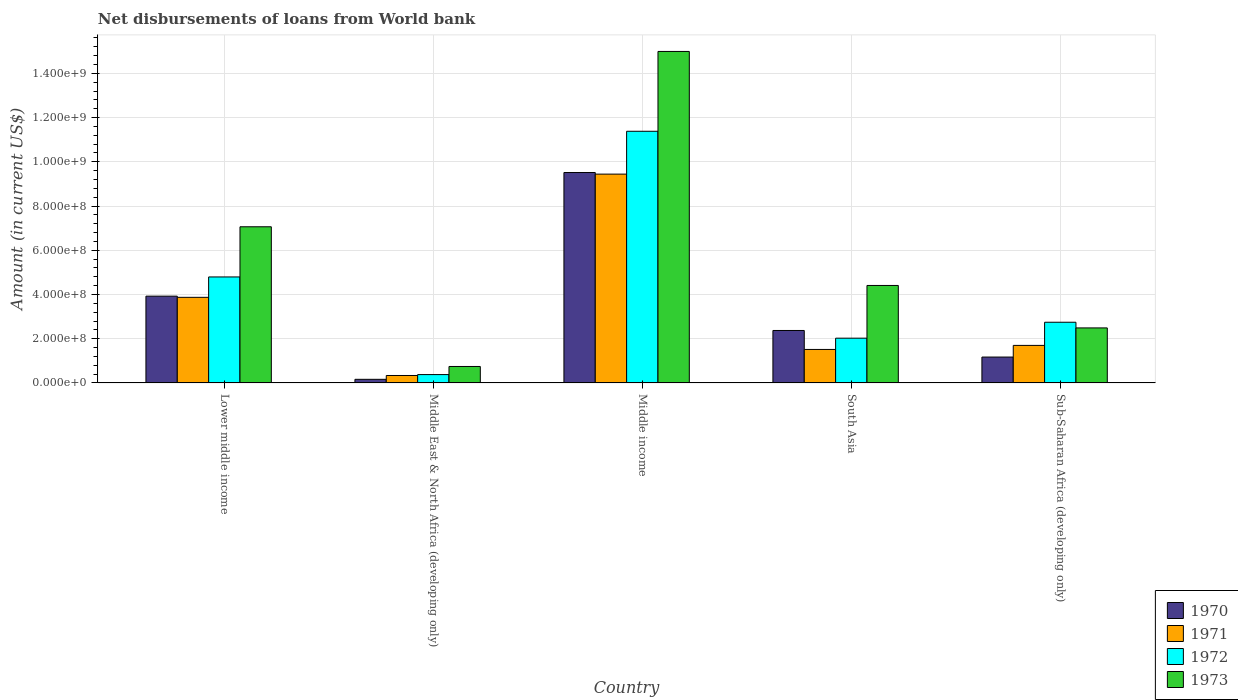Are the number of bars per tick equal to the number of legend labels?
Offer a very short reply. Yes. How many bars are there on the 5th tick from the right?
Make the answer very short. 4. What is the label of the 5th group of bars from the left?
Make the answer very short. Sub-Saharan Africa (developing only). In how many cases, is the number of bars for a given country not equal to the number of legend labels?
Provide a succinct answer. 0. What is the amount of loan disbursed from World Bank in 1973 in Lower middle income?
Give a very brief answer. 7.06e+08. Across all countries, what is the maximum amount of loan disbursed from World Bank in 1973?
Offer a terse response. 1.50e+09. Across all countries, what is the minimum amount of loan disbursed from World Bank in 1972?
Give a very brief answer. 3.77e+07. In which country was the amount of loan disbursed from World Bank in 1972 maximum?
Offer a very short reply. Middle income. In which country was the amount of loan disbursed from World Bank in 1973 minimum?
Keep it short and to the point. Middle East & North Africa (developing only). What is the total amount of loan disbursed from World Bank in 1970 in the graph?
Ensure brevity in your answer.  1.71e+09. What is the difference between the amount of loan disbursed from World Bank in 1971 in Middle income and that in South Asia?
Make the answer very short. 7.93e+08. What is the difference between the amount of loan disbursed from World Bank in 1971 in Middle income and the amount of loan disbursed from World Bank in 1972 in South Asia?
Provide a succinct answer. 7.42e+08. What is the average amount of loan disbursed from World Bank in 1973 per country?
Your answer should be very brief. 5.94e+08. What is the difference between the amount of loan disbursed from World Bank of/in 1970 and amount of loan disbursed from World Bank of/in 1971 in Lower middle income?
Offer a very short reply. 5.37e+06. In how many countries, is the amount of loan disbursed from World Bank in 1973 greater than 1320000000 US$?
Provide a succinct answer. 1. What is the ratio of the amount of loan disbursed from World Bank in 1971 in Middle income to that in Sub-Saharan Africa (developing only)?
Provide a succinct answer. 5.56. Is the amount of loan disbursed from World Bank in 1971 in Middle income less than that in Sub-Saharan Africa (developing only)?
Give a very brief answer. No. What is the difference between the highest and the second highest amount of loan disbursed from World Bank in 1972?
Your answer should be very brief. 8.63e+08. What is the difference between the highest and the lowest amount of loan disbursed from World Bank in 1970?
Offer a terse response. 9.35e+08. Is it the case that in every country, the sum of the amount of loan disbursed from World Bank in 1972 and amount of loan disbursed from World Bank in 1971 is greater than the sum of amount of loan disbursed from World Bank in 1970 and amount of loan disbursed from World Bank in 1973?
Keep it short and to the point. No. What does the 1st bar from the left in Middle East & North Africa (developing only) represents?
Keep it short and to the point. 1970. What does the 4th bar from the right in Middle East & North Africa (developing only) represents?
Keep it short and to the point. 1970. Is it the case that in every country, the sum of the amount of loan disbursed from World Bank in 1971 and amount of loan disbursed from World Bank in 1970 is greater than the amount of loan disbursed from World Bank in 1972?
Provide a short and direct response. Yes. How many bars are there?
Offer a terse response. 20. Does the graph contain any zero values?
Ensure brevity in your answer.  No. Does the graph contain grids?
Ensure brevity in your answer.  Yes. Where does the legend appear in the graph?
Give a very brief answer. Bottom right. What is the title of the graph?
Your response must be concise. Net disbursements of loans from World bank. Does "2011" appear as one of the legend labels in the graph?
Provide a short and direct response. No. What is the label or title of the Y-axis?
Provide a succinct answer. Amount (in current US$). What is the Amount (in current US$) of 1970 in Lower middle income?
Keep it short and to the point. 3.92e+08. What is the Amount (in current US$) of 1971 in Lower middle income?
Your answer should be very brief. 3.87e+08. What is the Amount (in current US$) in 1972 in Lower middle income?
Provide a succinct answer. 4.79e+08. What is the Amount (in current US$) of 1973 in Lower middle income?
Provide a succinct answer. 7.06e+08. What is the Amount (in current US$) of 1970 in Middle East & North Africa (developing only)?
Give a very brief answer. 1.64e+07. What is the Amount (in current US$) of 1971 in Middle East & North Africa (developing only)?
Offer a terse response. 3.37e+07. What is the Amount (in current US$) of 1972 in Middle East & North Africa (developing only)?
Offer a terse response. 3.77e+07. What is the Amount (in current US$) of 1973 in Middle East & North Africa (developing only)?
Make the answer very short. 7.45e+07. What is the Amount (in current US$) of 1970 in Middle income?
Ensure brevity in your answer.  9.51e+08. What is the Amount (in current US$) in 1971 in Middle income?
Keep it short and to the point. 9.44e+08. What is the Amount (in current US$) in 1972 in Middle income?
Provide a short and direct response. 1.14e+09. What is the Amount (in current US$) of 1973 in Middle income?
Your answer should be compact. 1.50e+09. What is the Amount (in current US$) of 1970 in South Asia?
Your answer should be very brief. 2.37e+08. What is the Amount (in current US$) in 1971 in South Asia?
Your answer should be compact. 1.51e+08. What is the Amount (in current US$) of 1972 in South Asia?
Your answer should be very brief. 2.02e+08. What is the Amount (in current US$) of 1973 in South Asia?
Make the answer very short. 4.41e+08. What is the Amount (in current US$) of 1970 in Sub-Saharan Africa (developing only)?
Offer a very short reply. 1.17e+08. What is the Amount (in current US$) in 1971 in Sub-Saharan Africa (developing only)?
Provide a short and direct response. 1.70e+08. What is the Amount (in current US$) of 1972 in Sub-Saharan Africa (developing only)?
Offer a terse response. 2.74e+08. What is the Amount (in current US$) in 1973 in Sub-Saharan Africa (developing only)?
Offer a very short reply. 2.49e+08. Across all countries, what is the maximum Amount (in current US$) of 1970?
Offer a very short reply. 9.51e+08. Across all countries, what is the maximum Amount (in current US$) in 1971?
Provide a short and direct response. 9.44e+08. Across all countries, what is the maximum Amount (in current US$) of 1972?
Offer a very short reply. 1.14e+09. Across all countries, what is the maximum Amount (in current US$) of 1973?
Provide a short and direct response. 1.50e+09. Across all countries, what is the minimum Amount (in current US$) in 1970?
Provide a succinct answer. 1.64e+07. Across all countries, what is the minimum Amount (in current US$) of 1971?
Your answer should be very brief. 3.37e+07. Across all countries, what is the minimum Amount (in current US$) of 1972?
Offer a terse response. 3.77e+07. Across all countries, what is the minimum Amount (in current US$) in 1973?
Your answer should be very brief. 7.45e+07. What is the total Amount (in current US$) of 1970 in the graph?
Provide a short and direct response. 1.71e+09. What is the total Amount (in current US$) in 1971 in the graph?
Your answer should be compact. 1.69e+09. What is the total Amount (in current US$) in 1972 in the graph?
Provide a short and direct response. 2.13e+09. What is the total Amount (in current US$) in 1973 in the graph?
Your answer should be very brief. 2.97e+09. What is the difference between the Amount (in current US$) of 1970 in Lower middle income and that in Middle East & North Africa (developing only)?
Ensure brevity in your answer.  3.76e+08. What is the difference between the Amount (in current US$) in 1971 in Lower middle income and that in Middle East & North Africa (developing only)?
Make the answer very short. 3.53e+08. What is the difference between the Amount (in current US$) in 1972 in Lower middle income and that in Middle East & North Africa (developing only)?
Make the answer very short. 4.41e+08. What is the difference between the Amount (in current US$) of 1973 in Lower middle income and that in Middle East & North Africa (developing only)?
Offer a terse response. 6.32e+08. What is the difference between the Amount (in current US$) of 1970 in Lower middle income and that in Middle income?
Give a very brief answer. -5.59e+08. What is the difference between the Amount (in current US$) in 1971 in Lower middle income and that in Middle income?
Your answer should be very brief. -5.57e+08. What is the difference between the Amount (in current US$) in 1972 in Lower middle income and that in Middle income?
Ensure brevity in your answer.  -6.59e+08. What is the difference between the Amount (in current US$) in 1973 in Lower middle income and that in Middle income?
Provide a succinct answer. -7.93e+08. What is the difference between the Amount (in current US$) of 1970 in Lower middle income and that in South Asia?
Make the answer very short. 1.55e+08. What is the difference between the Amount (in current US$) of 1971 in Lower middle income and that in South Asia?
Provide a succinct answer. 2.36e+08. What is the difference between the Amount (in current US$) of 1972 in Lower middle income and that in South Asia?
Your answer should be compact. 2.77e+08. What is the difference between the Amount (in current US$) in 1973 in Lower middle income and that in South Asia?
Your answer should be very brief. 2.65e+08. What is the difference between the Amount (in current US$) in 1970 in Lower middle income and that in Sub-Saharan Africa (developing only)?
Give a very brief answer. 2.75e+08. What is the difference between the Amount (in current US$) in 1971 in Lower middle income and that in Sub-Saharan Africa (developing only)?
Offer a terse response. 2.17e+08. What is the difference between the Amount (in current US$) in 1972 in Lower middle income and that in Sub-Saharan Africa (developing only)?
Ensure brevity in your answer.  2.05e+08. What is the difference between the Amount (in current US$) of 1973 in Lower middle income and that in Sub-Saharan Africa (developing only)?
Keep it short and to the point. 4.57e+08. What is the difference between the Amount (in current US$) in 1970 in Middle East & North Africa (developing only) and that in Middle income?
Make the answer very short. -9.35e+08. What is the difference between the Amount (in current US$) of 1971 in Middle East & North Africa (developing only) and that in Middle income?
Provide a succinct answer. -9.10e+08. What is the difference between the Amount (in current US$) in 1972 in Middle East & North Africa (developing only) and that in Middle income?
Your answer should be very brief. -1.10e+09. What is the difference between the Amount (in current US$) of 1973 in Middle East & North Africa (developing only) and that in Middle income?
Offer a terse response. -1.42e+09. What is the difference between the Amount (in current US$) of 1970 in Middle East & North Africa (developing only) and that in South Asia?
Make the answer very short. -2.21e+08. What is the difference between the Amount (in current US$) in 1971 in Middle East & North Africa (developing only) and that in South Asia?
Make the answer very short. -1.18e+08. What is the difference between the Amount (in current US$) of 1972 in Middle East & North Africa (developing only) and that in South Asia?
Ensure brevity in your answer.  -1.65e+08. What is the difference between the Amount (in current US$) in 1973 in Middle East & North Africa (developing only) and that in South Asia?
Make the answer very short. -3.66e+08. What is the difference between the Amount (in current US$) of 1970 in Middle East & North Africa (developing only) and that in Sub-Saharan Africa (developing only)?
Make the answer very short. -1.01e+08. What is the difference between the Amount (in current US$) of 1971 in Middle East & North Africa (developing only) and that in Sub-Saharan Africa (developing only)?
Your answer should be compact. -1.36e+08. What is the difference between the Amount (in current US$) in 1972 in Middle East & North Africa (developing only) and that in Sub-Saharan Africa (developing only)?
Keep it short and to the point. -2.37e+08. What is the difference between the Amount (in current US$) of 1973 in Middle East & North Africa (developing only) and that in Sub-Saharan Africa (developing only)?
Give a very brief answer. -1.74e+08. What is the difference between the Amount (in current US$) of 1970 in Middle income and that in South Asia?
Your answer should be very brief. 7.14e+08. What is the difference between the Amount (in current US$) of 1971 in Middle income and that in South Asia?
Your answer should be compact. 7.93e+08. What is the difference between the Amount (in current US$) in 1972 in Middle income and that in South Asia?
Your answer should be very brief. 9.36e+08. What is the difference between the Amount (in current US$) in 1973 in Middle income and that in South Asia?
Offer a very short reply. 1.06e+09. What is the difference between the Amount (in current US$) in 1970 in Middle income and that in Sub-Saharan Africa (developing only)?
Make the answer very short. 8.34e+08. What is the difference between the Amount (in current US$) in 1971 in Middle income and that in Sub-Saharan Africa (developing only)?
Give a very brief answer. 7.74e+08. What is the difference between the Amount (in current US$) of 1972 in Middle income and that in Sub-Saharan Africa (developing only)?
Offer a very short reply. 8.63e+08. What is the difference between the Amount (in current US$) in 1973 in Middle income and that in Sub-Saharan Africa (developing only)?
Ensure brevity in your answer.  1.25e+09. What is the difference between the Amount (in current US$) in 1970 in South Asia and that in Sub-Saharan Africa (developing only)?
Your answer should be compact. 1.20e+08. What is the difference between the Amount (in current US$) of 1971 in South Asia and that in Sub-Saharan Africa (developing only)?
Provide a succinct answer. -1.83e+07. What is the difference between the Amount (in current US$) of 1972 in South Asia and that in Sub-Saharan Africa (developing only)?
Your response must be concise. -7.21e+07. What is the difference between the Amount (in current US$) in 1973 in South Asia and that in Sub-Saharan Africa (developing only)?
Your answer should be very brief. 1.92e+08. What is the difference between the Amount (in current US$) of 1970 in Lower middle income and the Amount (in current US$) of 1971 in Middle East & North Africa (developing only)?
Your answer should be compact. 3.59e+08. What is the difference between the Amount (in current US$) of 1970 in Lower middle income and the Amount (in current US$) of 1972 in Middle East & North Africa (developing only)?
Your answer should be compact. 3.55e+08. What is the difference between the Amount (in current US$) in 1970 in Lower middle income and the Amount (in current US$) in 1973 in Middle East & North Africa (developing only)?
Offer a terse response. 3.18e+08. What is the difference between the Amount (in current US$) in 1971 in Lower middle income and the Amount (in current US$) in 1972 in Middle East & North Africa (developing only)?
Keep it short and to the point. 3.49e+08. What is the difference between the Amount (in current US$) of 1971 in Lower middle income and the Amount (in current US$) of 1973 in Middle East & North Africa (developing only)?
Provide a succinct answer. 3.13e+08. What is the difference between the Amount (in current US$) of 1972 in Lower middle income and the Amount (in current US$) of 1973 in Middle East & North Africa (developing only)?
Provide a short and direct response. 4.05e+08. What is the difference between the Amount (in current US$) of 1970 in Lower middle income and the Amount (in current US$) of 1971 in Middle income?
Keep it short and to the point. -5.52e+08. What is the difference between the Amount (in current US$) of 1970 in Lower middle income and the Amount (in current US$) of 1972 in Middle income?
Your answer should be very brief. -7.46e+08. What is the difference between the Amount (in current US$) in 1970 in Lower middle income and the Amount (in current US$) in 1973 in Middle income?
Your answer should be compact. -1.11e+09. What is the difference between the Amount (in current US$) in 1971 in Lower middle income and the Amount (in current US$) in 1972 in Middle income?
Ensure brevity in your answer.  -7.51e+08. What is the difference between the Amount (in current US$) in 1971 in Lower middle income and the Amount (in current US$) in 1973 in Middle income?
Offer a terse response. -1.11e+09. What is the difference between the Amount (in current US$) of 1972 in Lower middle income and the Amount (in current US$) of 1973 in Middle income?
Make the answer very short. -1.02e+09. What is the difference between the Amount (in current US$) of 1970 in Lower middle income and the Amount (in current US$) of 1971 in South Asia?
Keep it short and to the point. 2.41e+08. What is the difference between the Amount (in current US$) of 1970 in Lower middle income and the Amount (in current US$) of 1972 in South Asia?
Your response must be concise. 1.90e+08. What is the difference between the Amount (in current US$) in 1970 in Lower middle income and the Amount (in current US$) in 1973 in South Asia?
Ensure brevity in your answer.  -4.83e+07. What is the difference between the Amount (in current US$) of 1971 in Lower middle income and the Amount (in current US$) of 1972 in South Asia?
Ensure brevity in your answer.  1.85e+08. What is the difference between the Amount (in current US$) in 1971 in Lower middle income and the Amount (in current US$) in 1973 in South Asia?
Your answer should be compact. -5.37e+07. What is the difference between the Amount (in current US$) of 1972 in Lower middle income and the Amount (in current US$) of 1973 in South Asia?
Your answer should be compact. 3.85e+07. What is the difference between the Amount (in current US$) in 1970 in Lower middle income and the Amount (in current US$) in 1971 in Sub-Saharan Africa (developing only)?
Your response must be concise. 2.23e+08. What is the difference between the Amount (in current US$) of 1970 in Lower middle income and the Amount (in current US$) of 1972 in Sub-Saharan Africa (developing only)?
Provide a short and direct response. 1.18e+08. What is the difference between the Amount (in current US$) in 1970 in Lower middle income and the Amount (in current US$) in 1973 in Sub-Saharan Africa (developing only)?
Offer a terse response. 1.44e+08. What is the difference between the Amount (in current US$) in 1971 in Lower middle income and the Amount (in current US$) in 1972 in Sub-Saharan Africa (developing only)?
Give a very brief answer. 1.13e+08. What is the difference between the Amount (in current US$) of 1971 in Lower middle income and the Amount (in current US$) of 1973 in Sub-Saharan Africa (developing only)?
Give a very brief answer. 1.38e+08. What is the difference between the Amount (in current US$) in 1972 in Lower middle income and the Amount (in current US$) in 1973 in Sub-Saharan Africa (developing only)?
Ensure brevity in your answer.  2.30e+08. What is the difference between the Amount (in current US$) of 1970 in Middle East & North Africa (developing only) and the Amount (in current US$) of 1971 in Middle income?
Provide a short and direct response. -9.28e+08. What is the difference between the Amount (in current US$) in 1970 in Middle East & North Africa (developing only) and the Amount (in current US$) in 1972 in Middle income?
Your answer should be very brief. -1.12e+09. What is the difference between the Amount (in current US$) in 1970 in Middle East & North Africa (developing only) and the Amount (in current US$) in 1973 in Middle income?
Your response must be concise. -1.48e+09. What is the difference between the Amount (in current US$) in 1971 in Middle East & North Africa (developing only) and the Amount (in current US$) in 1972 in Middle income?
Keep it short and to the point. -1.10e+09. What is the difference between the Amount (in current US$) in 1971 in Middle East & North Africa (developing only) and the Amount (in current US$) in 1973 in Middle income?
Offer a very short reply. -1.47e+09. What is the difference between the Amount (in current US$) of 1972 in Middle East & North Africa (developing only) and the Amount (in current US$) of 1973 in Middle income?
Give a very brief answer. -1.46e+09. What is the difference between the Amount (in current US$) in 1970 in Middle East & North Africa (developing only) and the Amount (in current US$) in 1971 in South Asia?
Your answer should be very brief. -1.35e+08. What is the difference between the Amount (in current US$) of 1970 in Middle East & North Africa (developing only) and the Amount (in current US$) of 1972 in South Asia?
Your answer should be very brief. -1.86e+08. What is the difference between the Amount (in current US$) of 1970 in Middle East & North Africa (developing only) and the Amount (in current US$) of 1973 in South Asia?
Your response must be concise. -4.24e+08. What is the difference between the Amount (in current US$) of 1971 in Middle East & North Africa (developing only) and the Amount (in current US$) of 1972 in South Asia?
Give a very brief answer. -1.69e+08. What is the difference between the Amount (in current US$) of 1971 in Middle East & North Africa (developing only) and the Amount (in current US$) of 1973 in South Asia?
Keep it short and to the point. -4.07e+08. What is the difference between the Amount (in current US$) in 1972 in Middle East & North Africa (developing only) and the Amount (in current US$) in 1973 in South Asia?
Your response must be concise. -4.03e+08. What is the difference between the Amount (in current US$) of 1970 in Middle East & North Africa (developing only) and the Amount (in current US$) of 1971 in Sub-Saharan Africa (developing only)?
Your answer should be very brief. -1.53e+08. What is the difference between the Amount (in current US$) in 1970 in Middle East & North Africa (developing only) and the Amount (in current US$) in 1972 in Sub-Saharan Africa (developing only)?
Offer a very short reply. -2.58e+08. What is the difference between the Amount (in current US$) of 1970 in Middle East & North Africa (developing only) and the Amount (in current US$) of 1973 in Sub-Saharan Africa (developing only)?
Make the answer very short. -2.32e+08. What is the difference between the Amount (in current US$) of 1971 in Middle East & North Africa (developing only) and the Amount (in current US$) of 1972 in Sub-Saharan Africa (developing only)?
Keep it short and to the point. -2.41e+08. What is the difference between the Amount (in current US$) in 1971 in Middle East & North Africa (developing only) and the Amount (in current US$) in 1973 in Sub-Saharan Africa (developing only)?
Ensure brevity in your answer.  -2.15e+08. What is the difference between the Amount (in current US$) of 1972 in Middle East & North Africa (developing only) and the Amount (in current US$) of 1973 in Sub-Saharan Africa (developing only)?
Provide a succinct answer. -2.11e+08. What is the difference between the Amount (in current US$) in 1970 in Middle income and the Amount (in current US$) in 1971 in South Asia?
Provide a succinct answer. 8.00e+08. What is the difference between the Amount (in current US$) in 1970 in Middle income and the Amount (in current US$) in 1972 in South Asia?
Keep it short and to the point. 7.49e+08. What is the difference between the Amount (in current US$) in 1970 in Middle income and the Amount (in current US$) in 1973 in South Asia?
Ensure brevity in your answer.  5.11e+08. What is the difference between the Amount (in current US$) of 1971 in Middle income and the Amount (in current US$) of 1972 in South Asia?
Give a very brief answer. 7.42e+08. What is the difference between the Amount (in current US$) in 1971 in Middle income and the Amount (in current US$) in 1973 in South Asia?
Ensure brevity in your answer.  5.03e+08. What is the difference between the Amount (in current US$) of 1972 in Middle income and the Amount (in current US$) of 1973 in South Asia?
Ensure brevity in your answer.  6.97e+08. What is the difference between the Amount (in current US$) of 1970 in Middle income and the Amount (in current US$) of 1971 in Sub-Saharan Africa (developing only)?
Offer a very short reply. 7.82e+08. What is the difference between the Amount (in current US$) in 1970 in Middle income and the Amount (in current US$) in 1972 in Sub-Saharan Africa (developing only)?
Your answer should be compact. 6.77e+08. What is the difference between the Amount (in current US$) of 1970 in Middle income and the Amount (in current US$) of 1973 in Sub-Saharan Africa (developing only)?
Offer a terse response. 7.03e+08. What is the difference between the Amount (in current US$) in 1971 in Middle income and the Amount (in current US$) in 1972 in Sub-Saharan Africa (developing only)?
Provide a short and direct response. 6.70e+08. What is the difference between the Amount (in current US$) in 1971 in Middle income and the Amount (in current US$) in 1973 in Sub-Saharan Africa (developing only)?
Make the answer very short. 6.95e+08. What is the difference between the Amount (in current US$) of 1972 in Middle income and the Amount (in current US$) of 1973 in Sub-Saharan Africa (developing only)?
Ensure brevity in your answer.  8.89e+08. What is the difference between the Amount (in current US$) in 1970 in South Asia and the Amount (in current US$) in 1971 in Sub-Saharan Africa (developing only)?
Offer a terse response. 6.75e+07. What is the difference between the Amount (in current US$) of 1970 in South Asia and the Amount (in current US$) of 1972 in Sub-Saharan Africa (developing only)?
Provide a short and direct response. -3.73e+07. What is the difference between the Amount (in current US$) in 1970 in South Asia and the Amount (in current US$) in 1973 in Sub-Saharan Africa (developing only)?
Offer a terse response. -1.16e+07. What is the difference between the Amount (in current US$) in 1971 in South Asia and the Amount (in current US$) in 1972 in Sub-Saharan Africa (developing only)?
Provide a short and direct response. -1.23e+08. What is the difference between the Amount (in current US$) in 1971 in South Asia and the Amount (in current US$) in 1973 in Sub-Saharan Africa (developing only)?
Make the answer very short. -9.74e+07. What is the difference between the Amount (in current US$) in 1972 in South Asia and the Amount (in current US$) in 1973 in Sub-Saharan Africa (developing only)?
Offer a terse response. -4.65e+07. What is the average Amount (in current US$) of 1970 per country?
Your answer should be very brief. 3.43e+08. What is the average Amount (in current US$) in 1971 per country?
Provide a short and direct response. 3.37e+08. What is the average Amount (in current US$) in 1972 per country?
Give a very brief answer. 4.26e+08. What is the average Amount (in current US$) of 1973 per country?
Offer a terse response. 5.94e+08. What is the difference between the Amount (in current US$) in 1970 and Amount (in current US$) in 1971 in Lower middle income?
Your answer should be compact. 5.37e+06. What is the difference between the Amount (in current US$) of 1970 and Amount (in current US$) of 1972 in Lower middle income?
Your answer should be very brief. -8.68e+07. What is the difference between the Amount (in current US$) in 1970 and Amount (in current US$) in 1973 in Lower middle income?
Offer a very short reply. -3.14e+08. What is the difference between the Amount (in current US$) in 1971 and Amount (in current US$) in 1972 in Lower middle income?
Ensure brevity in your answer.  -9.22e+07. What is the difference between the Amount (in current US$) of 1971 and Amount (in current US$) of 1973 in Lower middle income?
Give a very brief answer. -3.19e+08. What is the difference between the Amount (in current US$) of 1972 and Amount (in current US$) of 1973 in Lower middle income?
Offer a very short reply. -2.27e+08. What is the difference between the Amount (in current US$) of 1970 and Amount (in current US$) of 1971 in Middle East & North Africa (developing only)?
Ensure brevity in your answer.  -1.73e+07. What is the difference between the Amount (in current US$) of 1970 and Amount (in current US$) of 1972 in Middle East & North Africa (developing only)?
Give a very brief answer. -2.14e+07. What is the difference between the Amount (in current US$) of 1970 and Amount (in current US$) of 1973 in Middle East & North Africa (developing only)?
Keep it short and to the point. -5.81e+07. What is the difference between the Amount (in current US$) of 1971 and Amount (in current US$) of 1972 in Middle East & North Africa (developing only)?
Provide a short and direct response. -4.06e+06. What is the difference between the Amount (in current US$) in 1971 and Amount (in current US$) in 1973 in Middle East & North Africa (developing only)?
Provide a short and direct response. -4.08e+07. What is the difference between the Amount (in current US$) of 1972 and Amount (in current US$) of 1973 in Middle East & North Africa (developing only)?
Your answer should be compact. -3.67e+07. What is the difference between the Amount (in current US$) in 1970 and Amount (in current US$) in 1971 in Middle income?
Provide a succinct answer. 7.21e+06. What is the difference between the Amount (in current US$) of 1970 and Amount (in current US$) of 1972 in Middle income?
Provide a short and direct response. -1.87e+08. What is the difference between the Amount (in current US$) of 1970 and Amount (in current US$) of 1973 in Middle income?
Make the answer very short. -5.47e+08. What is the difference between the Amount (in current US$) of 1971 and Amount (in current US$) of 1972 in Middle income?
Provide a succinct answer. -1.94e+08. What is the difference between the Amount (in current US$) of 1971 and Amount (in current US$) of 1973 in Middle income?
Offer a very short reply. -5.55e+08. What is the difference between the Amount (in current US$) of 1972 and Amount (in current US$) of 1973 in Middle income?
Your response must be concise. -3.61e+08. What is the difference between the Amount (in current US$) of 1970 and Amount (in current US$) of 1971 in South Asia?
Offer a very short reply. 8.58e+07. What is the difference between the Amount (in current US$) in 1970 and Amount (in current US$) in 1972 in South Asia?
Provide a succinct answer. 3.49e+07. What is the difference between the Amount (in current US$) in 1970 and Amount (in current US$) in 1973 in South Asia?
Ensure brevity in your answer.  -2.04e+08. What is the difference between the Amount (in current US$) in 1971 and Amount (in current US$) in 1972 in South Asia?
Your response must be concise. -5.09e+07. What is the difference between the Amount (in current US$) of 1971 and Amount (in current US$) of 1973 in South Asia?
Provide a succinct answer. -2.89e+08. What is the difference between the Amount (in current US$) in 1972 and Amount (in current US$) in 1973 in South Asia?
Make the answer very short. -2.38e+08. What is the difference between the Amount (in current US$) in 1970 and Amount (in current US$) in 1971 in Sub-Saharan Africa (developing only)?
Make the answer very short. -5.27e+07. What is the difference between the Amount (in current US$) in 1970 and Amount (in current US$) in 1972 in Sub-Saharan Africa (developing only)?
Give a very brief answer. -1.57e+08. What is the difference between the Amount (in current US$) in 1970 and Amount (in current US$) in 1973 in Sub-Saharan Africa (developing only)?
Your answer should be compact. -1.32e+08. What is the difference between the Amount (in current US$) of 1971 and Amount (in current US$) of 1972 in Sub-Saharan Africa (developing only)?
Keep it short and to the point. -1.05e+08. What is the difference between the Amount (in current US$) in 1971 and Amount (in current US$) in 1973 in Sub-Saharan Africa (developing only)?
Keep it short and to the point. -7.91e+07. What is the difference between the Amount (in current US$) of 1972 and Amount (in current US$) of 1973 in Sub-Saharan Africa (developing only)?
Ensure brevity in your answer.  2.57e+07. What is the ratio of the Amount (in current US$) in 1970 in Lower middle income to that in Middle East & North Africa (developing only)?
Your response must be concise. 23.99. What is the ratio of the Amount (in current US$) of 1971 in Lower middle income to that in Middle East & North Africa (developing only)?
Keep it short and to the point. 11.49. What is the ratio of the Amount (in current US$) of 1972 in Lower middle income to that in Middle East & North Africa (developing only)?
Offer a very short reply. 12.7. What is the ratio of the Amount (in current US$) in 1973 in Lower middle income to that in Middle East & North Africa (developing only)?
Your answer should be very brief. 9.48. What is the ratio of the Amount (in current US$) of 1970 in Lower middle income to that in Middle income?
Provide a succinct answer. 0.41. What is the ratio of the Amount (in current US$) in 1971 in Lower middle income to that in Middle income?
Offer a terse response. 0.41. What is the ratio of the Amount (in current US$) of 1972 in Lower middle income to that in Middle income?
Offer a terse response. 0.42. What is the ratio of the Amount (in current US$) of 1973 in Lower middle income to that in Middle income?
Give a very brief answer. 0.47. What is the ratio of the Amount (in current US$) of 1970 in Lower middle income to that in South Asia?
Provide a short and direct response. 1.65. What is the ratio of the Amount (in current US$) of 1971 in Lower middle income to that in South Asia?
Your response must be concise. 2.56. What is the ratio of the Amount (in current US$) in 1972 in Lower middle income to that in South Asia?
Offer a terse response. 2.37. What is the ratio of the Amount (in current US$) of 1973 in Lower middle income to that in South Asia?
Your response must be concise. 1.6. What is the ratio of the Amount (in current US$) in 1970 in Lower middle income to that in Sub-Saharan Africa (developing only)?
Keep it short and to the point. 3.35. What is the ratio of the Amount (in current US$) of 1971 in Lower middle income to that in Sub-Saharan Africa (developing only)?
Offer a very short reply. 2.28. What is the ratio of the Amount (in current US$) of 1972 in Lower middle income to that in Sub-Saharan Africa (developing only)?
Provide a succinct answer. 1.75. What is the ratio of the Amount (in current US$) of 1973 in Lower middle income to that in Sub-Saharan Africa (developing only)?
Your answer should be compact. 2.84. What is the ratio of the Amount (in current US$) in 1970 in Middle East & North Africa (developing only) to that in Middle income?
Ensure brevity in your answer.  0.02. What is the ratio of the Amount (in current US$) in 1971 in Middle East & North Africa (developing only) to that in Middle income?
Your answer should be very brief. 0.04. What is the ratio of the Amount (in current US$) in 1972 in Middle East & North Africa (developing only) to that in Middle income?
Provide a short and direct response. 0.03. What is the ratio of the Amount (in current US$) in 1973 in Middle East & North Africa (developing only) to that in Middle income?
Ensure brevity in your answer.  0.05. What is the ratio of the Amount (in current US$) in 1970 in Middle East & North Africa (developing only) to that in South Asia?
Provide a succinct answer. 0.07. What is the ratio of the Amount (in current US$) in 1971 in Middle East & North Africa (developing only) to that in South Asia?
Offer a very short reply. 0.22. What is the ratio of the Amount (in current US$) of 1972 in Middle East & North Africa (developing only) to that in South Asia?
Make the answer very short. 0.19. What is the ratio of the Amount (in current US$) of 1973 in Middle East & North Africa (developing only) to that in South Asia?
Your answer should be very brief. 0.17. What is the ratio of the Amount (in current US$) in 1970 in Middle East & North Africa (developing only) to that in Sub-Saharan Africa (developing only)?
Offer a terse response. 0.14. What is the ratio of the Amount (in current US$) in 1971 in Middle East & North Africa (developing only) to that in Sub-Saharan Africa (developing only)?
Keep it short and to the point. 0.2. What is the ratio of the Amount (in current US$) in 1972 in Middle East & North Africa (developing only) to that in Sub-Saharan Africa (developing only)?
Give a very brief answer. 0.14. What is the ratio of the Amount (in current US$) in 1973 in Middle East & North Africa (developing only) to that in Sub-Saharan Africa (developing only)?
Give a very brief answer. 0.3. What is the ratio of the Amount (in current US$) of 1970 in Middle income to that in South Asia?
Give a very brief answer. 4.01. What is the ratio of the Amount (in current US$) in 1971 in Middle income to that in South Asia?
Provide a succinct answer. 6.23. What is the ratio of the Amount (in current US$) in 1972 in Middle income to that in South Asia?
Give a very brief answer. 5.62. What is the ratio of the Amount (in current US$) in 1973 in Middle income to that in South Asia?
Keep it short and to the point. 3.4. What is the ratio of the Amount (in current US$) in 1970 in Middle income to that in Sub-Saharan Africa (developing only)?
Offer a terse response. 8.13. What is the ratio of the Amount (in current US$) of 1971 in Middle income to that in Sub-Saharan Africa (developing only)?
Make the answer very short. 5.56. What is the ratio of the Amount (in current US$) in 1972 in Middle income to that in Sub-Saharan Africa (developing only)?
Provide a succinct answer. 4.15. What is the ratio of the Amount (in current US$) of 1973 in Middle income to that in Sub-Saharan Africa (developing only)?
Your answer should be very brief. 6.02. What is the ratio of the Amount (in current US$) of 1970 in South Asia to that in Sub-Saharan Africa (developing only)?
Offer a very short reply. 2.03. What is the ratio of the Amount (in current US$) in 1971 in South Asia to that in Sub-Saharan Africa (developing only)?
Offer a very short reply. 0.89. What is the ratio of the Amount (in current US$) of 1972 in South Asia to that in Sub-Saharan Africa (developing only)?
Offer a terse response. 0.74. What is the ratio of the Amount (in current US$) of 1973 in South Asia to that in Sub-Saharan Africa (developing only)?
Ensure brevity in your answer.  1.77. What is the difference between the highest and the second highest Amount (in current US$) of 1970?
Ensure brevity in your answer.  5.59e+08. What is the difference between the highest and the second highest Amount (in current US$) in 1971?
Offer a terse response. 5.57e+08. What is the difference between the highest and the second highest Amount (in current US$) in 1972?
Your answer should be very brief. 6.59e+08. What is the difference between the highest and the second highest Amount (in current US$) of 1973?
Give a very brief answer. 7.93e+08. What is the difference between the highest and the lowest Amount (in current US$) in 1970?
Make the answer very short. 9.35e+08. What is the difference between the highest and the lowest Amount (in current US$) of 1971?
Provide a short and direct response. 9.10e+08. What is the difference between the highest and the lowest Amount (in current US$) in 1972?
Give a very brief answer. 1.10e+09. What is the difference between the highest and the lowest Amount (in current US$) in 1973?
Make the answer very short. 1.42e+09. 